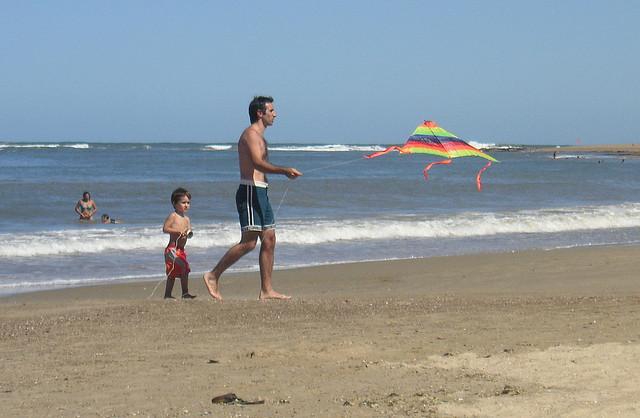Will the little boy be able to handle the kite by himself?
Concise answer only. No. Is there anybody in the water?
Write a very short answer. Yes. Is the kite only one color?
Answer briefly. No. 